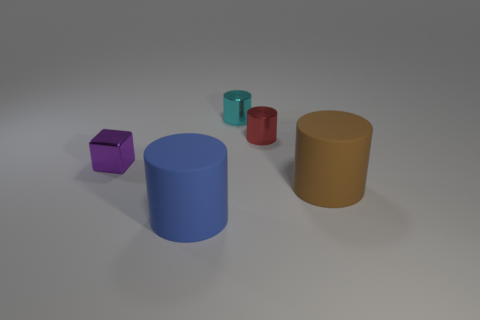Add 2 gray matte blocks. How many objects exist? 7 Subtract all cylinders. How many objects are left? 1 Add 2 tiny yellow matte balls. How many tiny yellow matte balls exist? 2 Subtract 0 red blocks. How many objects are left? 5 Subtract all cyan rubber cylinders. Subtract all small red shiny cylinders. How many objects are left? 4 Add 1 blue cylinders. How many blue cylinders are left? 2 